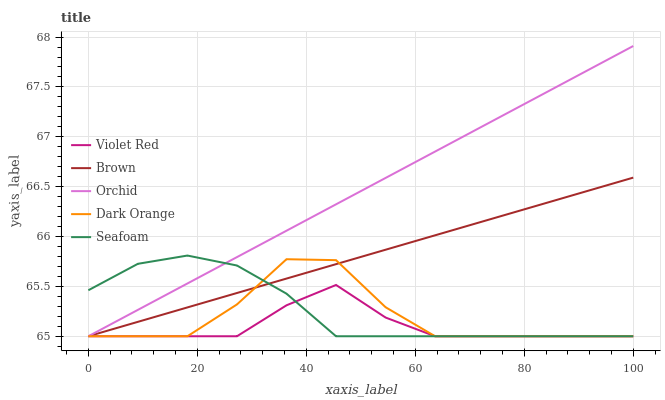Does Violet Red have the minimum area under the curve?
Answer yes or no. Yes. Does Orchid have the maximum area under the curve?
Answer yes or no. Yes. Does Brown have the minimum area under the curve?
Answer yes or no. No. Does Brown have the maximum area under the curve?
Answer yes or no. No. Is Brown the smoothest?
Answer yes or no. Yes. Is Dark Orange the roughest?
Answer yes or no. Yes. Is Violet Red the smoothest?
Answer yes or no. No. Is Violet Red the roughest?
Answer yes or no. No. Does Dark Orange have the lowest value?
Answer yes or no. Yes. Does Orchid have the highest value?
Answer yes or no. Yes. Does Brown have the highest value?
Answer yes or no. No. Does Violet Red intersect Orchid?
Answer yes or no. Yes. Is Violet Red less than Orchid?
Answer yes or no. No. Is Violet Red greater than Orchid?
Answer yes or no. No. 